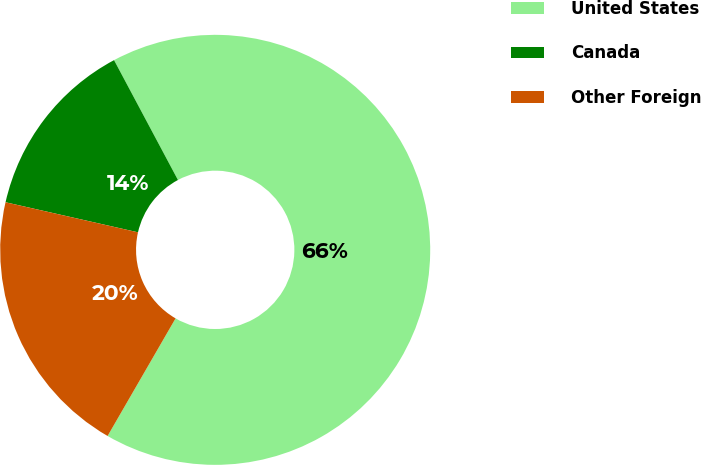Convert chart. <chart><loc_0><loc_0><loc_500><loc_500><pie_chart><fcel>United States<fcel>Canada<fcel>Other Foreign<nl><fcel>66.14%<fcel>13.65%<fcel>20.21%<nl></chart> 